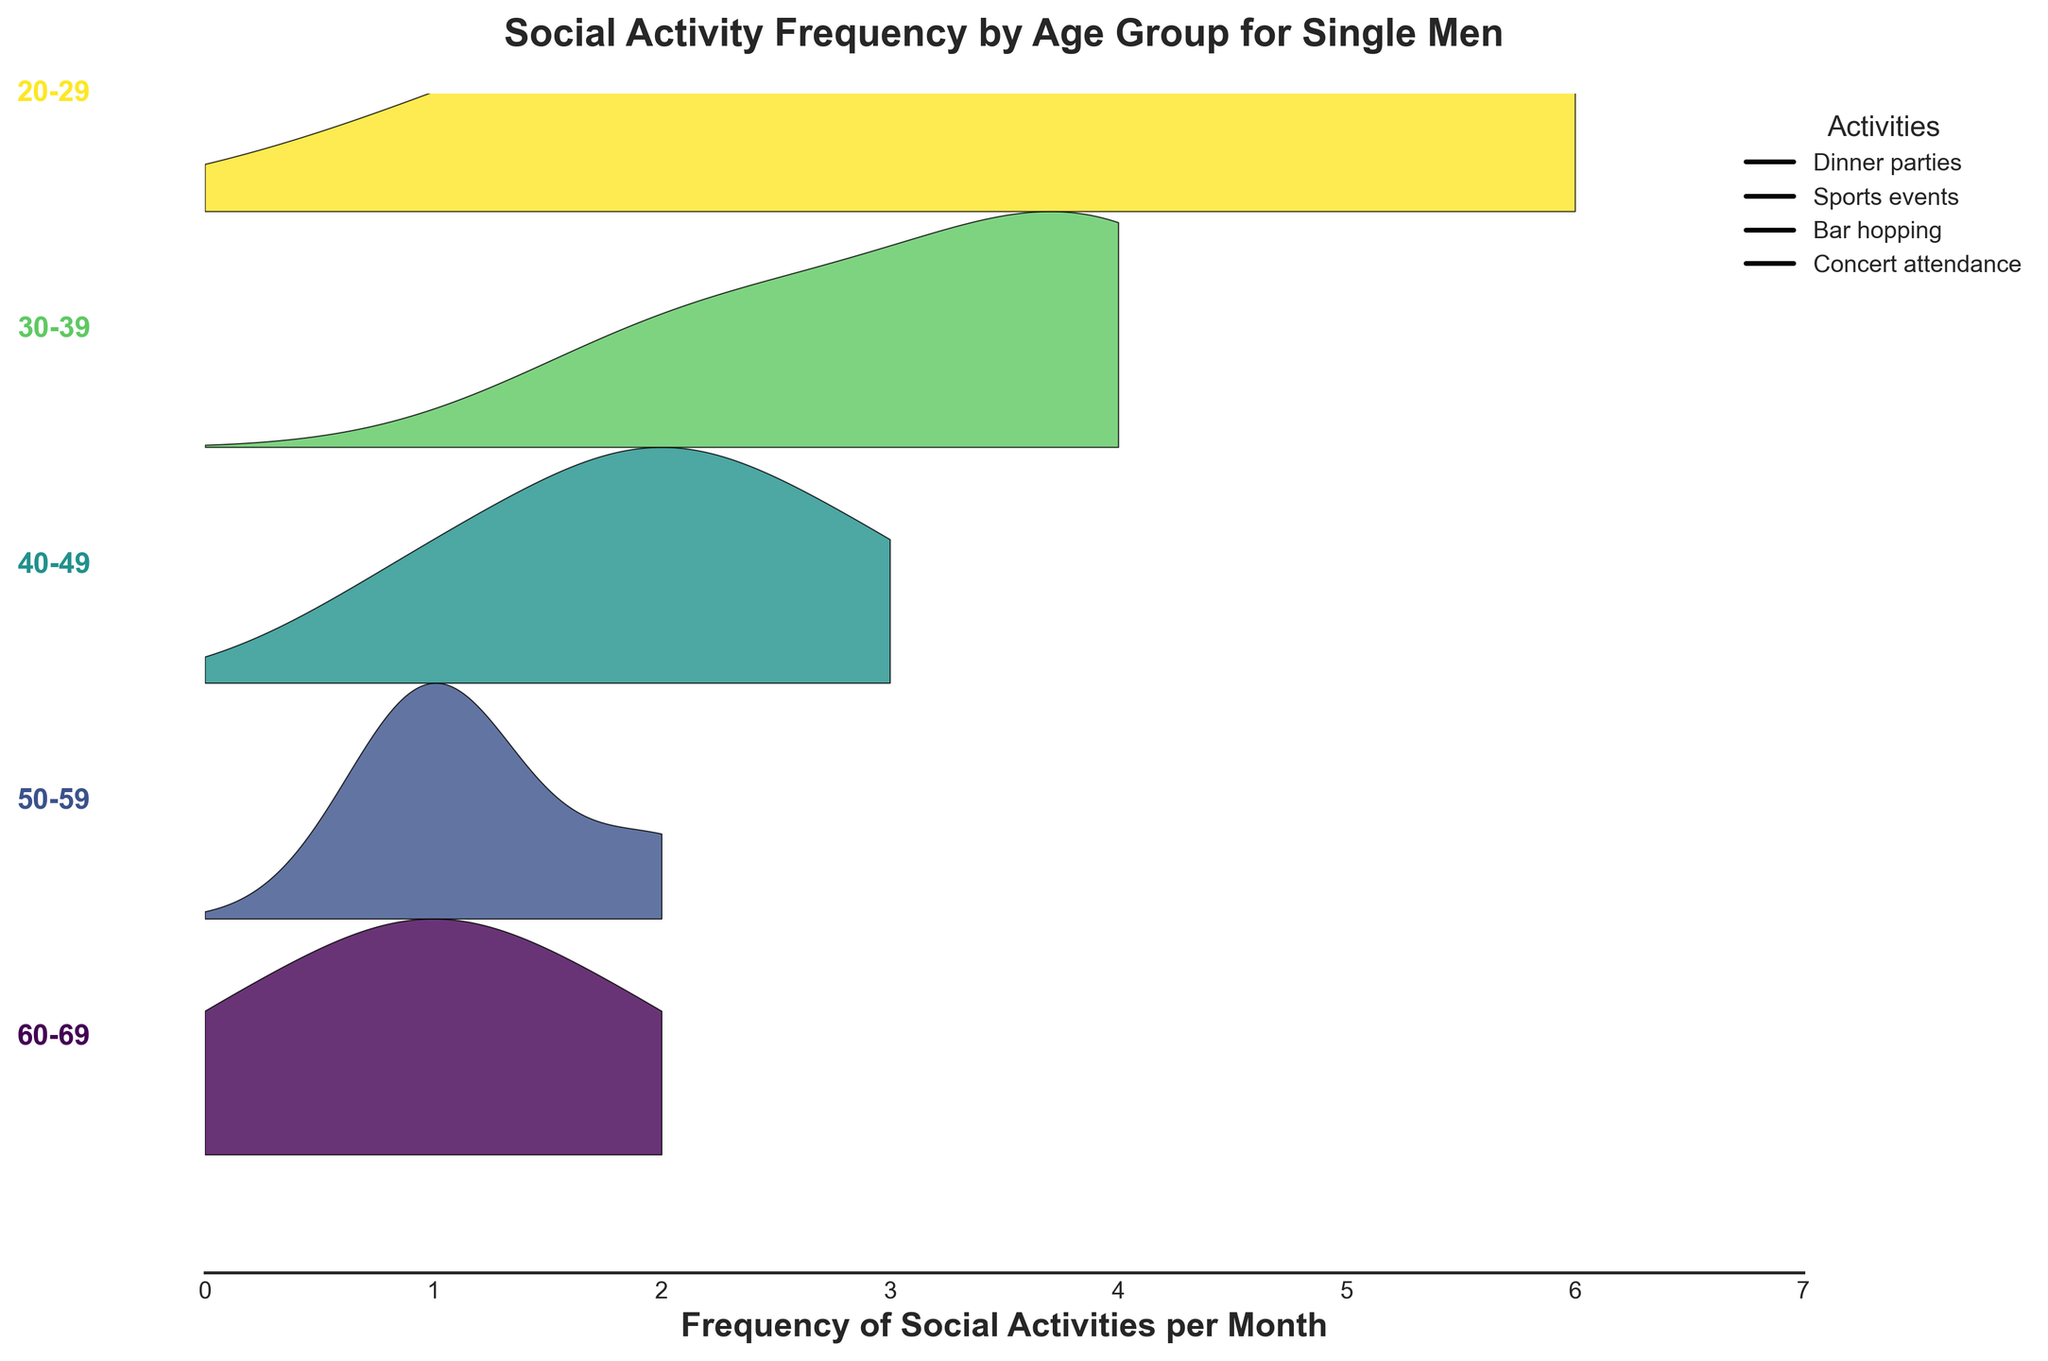what is the title of the figure? The title of the figure can be found at the top center of the plot. It is clearly mentioned in bold.
Answer: Social Activity Frequency by Age Group for Single Men How many age groups are represented in the figure? The number of age groups can be counted by looking at the labels on the left side of the ridgeline plot. These labels represent different age groups.
Answer: 5 Which age group has the highest frequency of social activities? To find the age group with the highest frequency, look for the group with the tallest ridgeline or the highest value on the x-axis.
Answer: 20-29 How does the frequency of Dinner parties change as age increases? Observe the ridgelines corresponding to Dinner parties across different age groups. Note the trend as you move from a younger age group to an older age group.
Answer: It decreases What is the least frequent activity for the age group 50-59? For the 50-59 age group, check the ridgeline corresponding to the lowest point on the x-axis.
Answer: Bar hopping, Concert attendance, Sports events What is the overall trend in social activity frequency as age increases? Sum up the ridgelines for each age group and observe the overall trend. Compare values from younger age groups to older ones.
Answer: It decreases Which age group has the similar frequency of Dinner parties and Concert attendance? Compare the ridgelines for Dinner parties and Concert attendance across different age groups and find the group where these frequencies are close.
Answer: 60-69 Which age group has the widest spread of activity frequencies? The age group with the widest spread will have the most diverse range of frequencies across different social activities, indicated by the distance between lows and highs.
Answer: 20-29 Among which age groups are Social activities like Bar hopping least frequent? Compare ridgelines corresponding to Bar hopping across all age groups and identify the groups where the frequency is at its lowest.
Answer: 50-59, 60-69 Compare the frequency of Sports events and Dinner parties for the age group 30-39. Which one is more frequent? For the age group 30-39, look at the ridgelines for Sports events and Dinner parties and compare their heights or x-axis values.
Answer: Dinner parties 